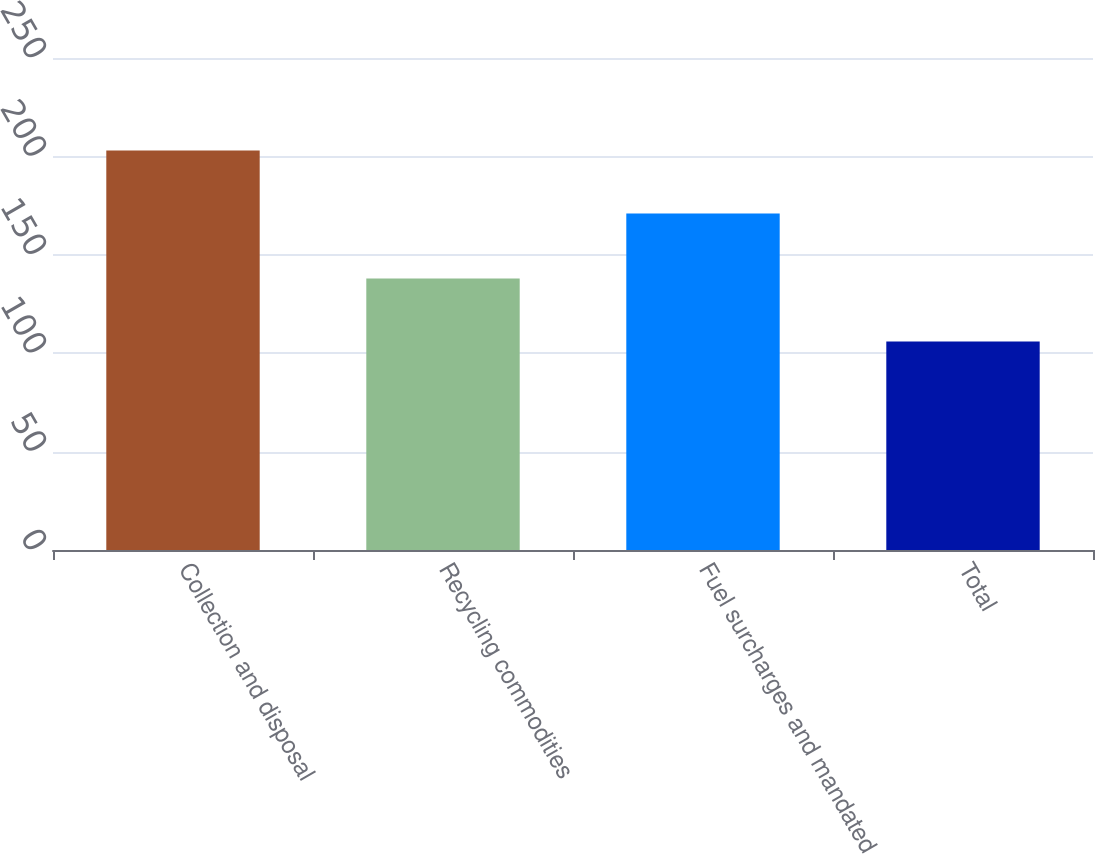Convert chart to OTSL. <chart><loc_0><loc_0><loc_500><loc_500><bar_chart><fcel>Collection and disposal<fcel>Recycling commodities<fcel>Fuel surcharges and mandated<fcel>Total<nl><fcel>203<fcel>138<fcel>171<fcel>106<nl></chart> 